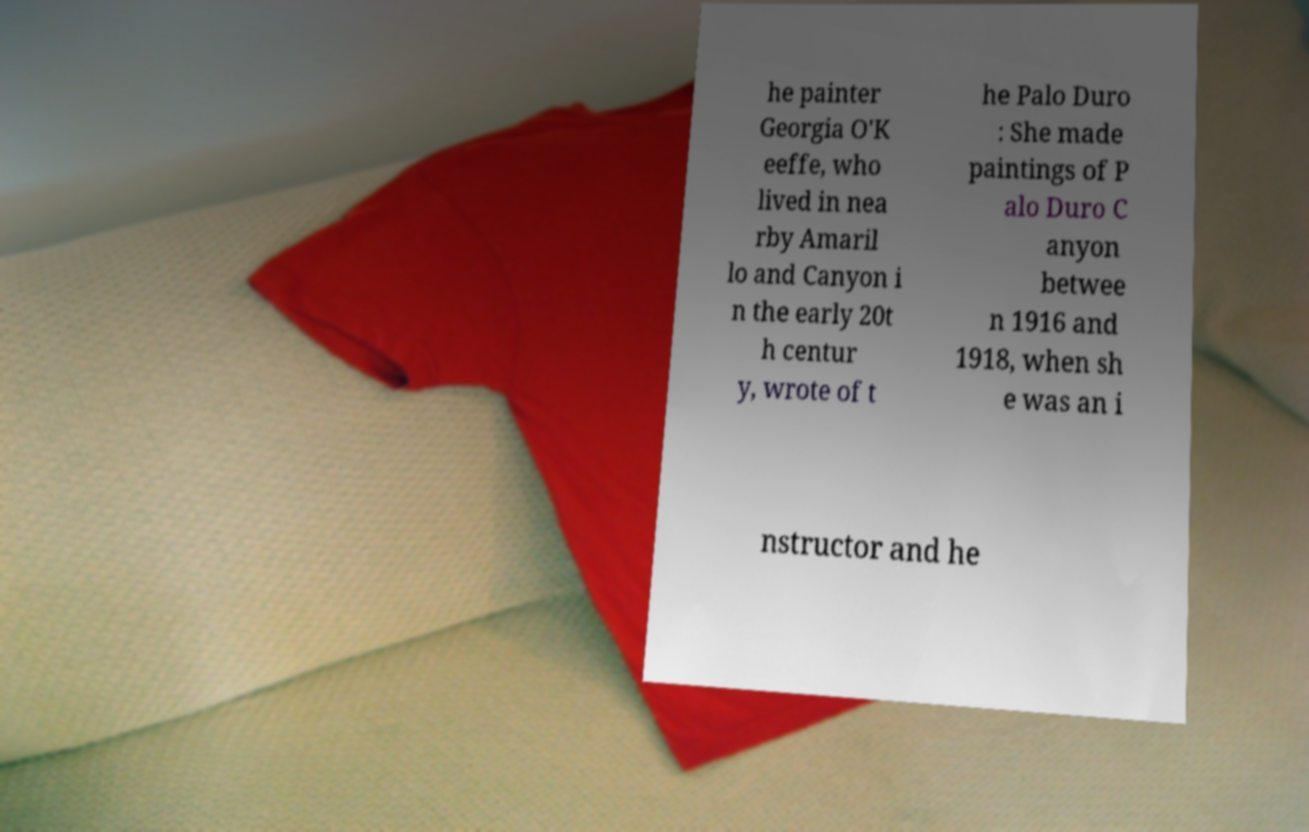I need the written content from this picture converted into text. Can you do that? he painter Georgia O'K eeffe, who lived in nea rby Amaril lo and Canyon i n the early 20t h centur y, wrote of t he Palo Duro : She made paintings of P alo Duro C anyon betwee n 1916 and 1918, when sh e was an i nstructor and he 